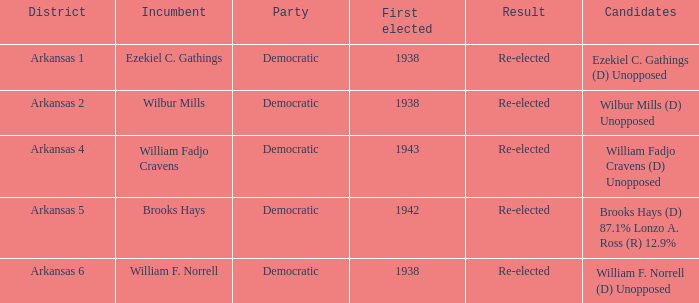In which initial years were any of the present incumbents elected for the first time? 1938.0. 